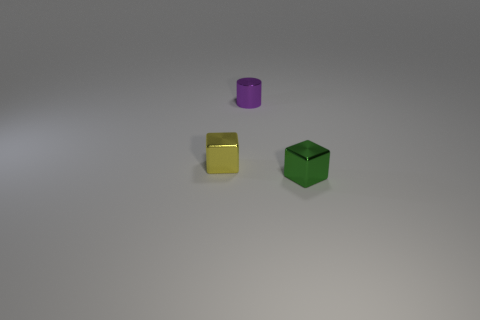Do the yellow thing that is to the left of the green object and the small thing that is right of the tiny cylinder have the same shape?
Give a very brief answer. Yes. How many balls are either tiny yellow metallic things or green shiny objects?
Give a very brief answer. 0. Is the number of tiny yellow cubes behind the tiny yellow cube less than the number of yellow shiny blocks?
Provide a succinct answer. Yes. What number of other things are made of the same material as the tiny yellow object?
Provide a succinct answer. 2. Do the yellow object and the green cube have the same size?
Give a very brief answer. Yes. What number of objects are either small metallic cubes in front of the tiny yellow shiny cube or small rubber things?
Your answer should be very brief. 1. What material is the cube that is to the right of the tiny cube behind the green object?
Provide a succinct answer. Metal. Is there a large blue object that has the same shape as the green object?
Your response must be concise. No. Do the purple metal cylinder and the block behind the tiny green metal cube have the same size?
Your response must be concise. Yes. What number of things are tiny metal things right of the tiny purple cylinder or small shiny things that are left of the tiny green thing?
Offer a very short reply. 3. 